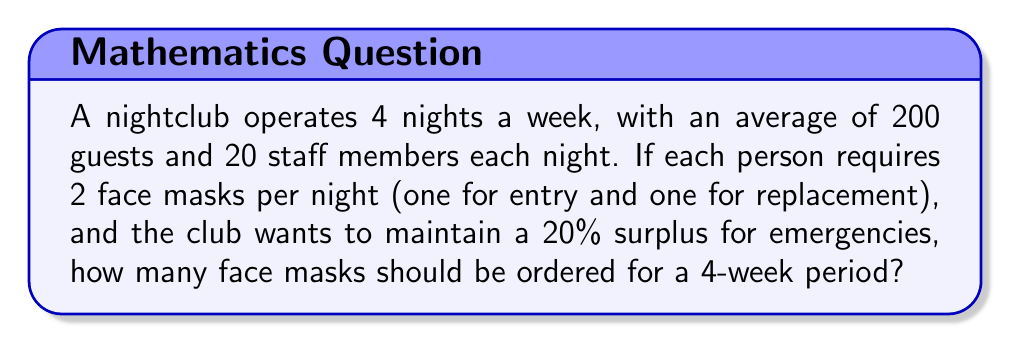Can you solve this math problem? Let's break this down step-by-step:

1. Calculate the number of people per night:
   Guests + Staff = 200 + 20 = 220 people

2. Calculate the number of masks needed per night:
   $220 \text{ people} \times 2 \text{ masks} = 440 \text{ masks}$

3. Calculate the number of masks needed per week:
   $440 \text{ masks} \times 4 \text{ nights} = 1,760 \text{ masks}$

4. Calculate the number of masks needed for 4 weeks:
   $1,760 \text{ masks} \times 4 \text{ weeks} = 7,040 \text{ masks}$

5. Add 20% surplus for emergencies:
   $7,040 \times 1.20 = 8,448 \text{ masks}$

Therefore, the club should order 8,448 face masks for a 4-week period.
Answer: 8,448 masks 